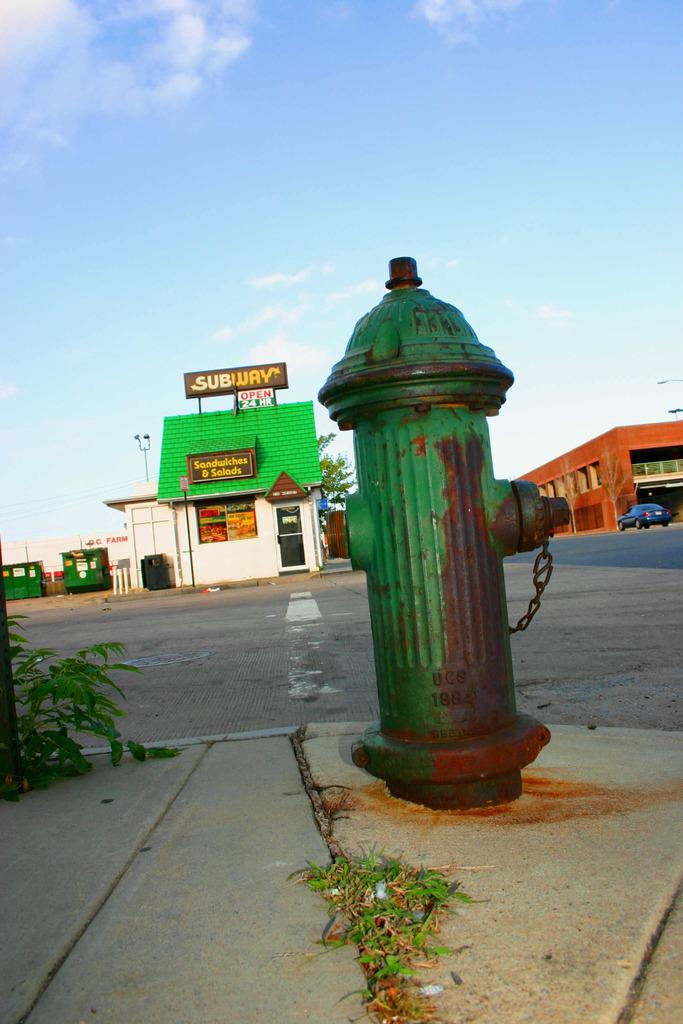<image>
Offer a succinct explanation of the picture presented. Green firehydrant in front of a building that says "SUBWAY". 